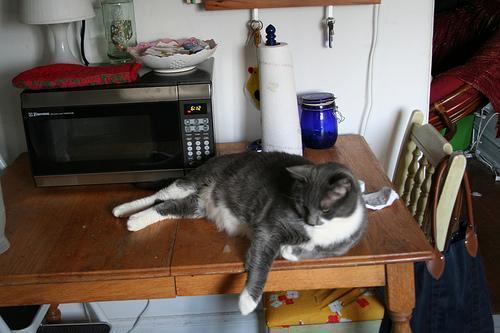How many chairs are there?
Give a very brief answer. 1. 